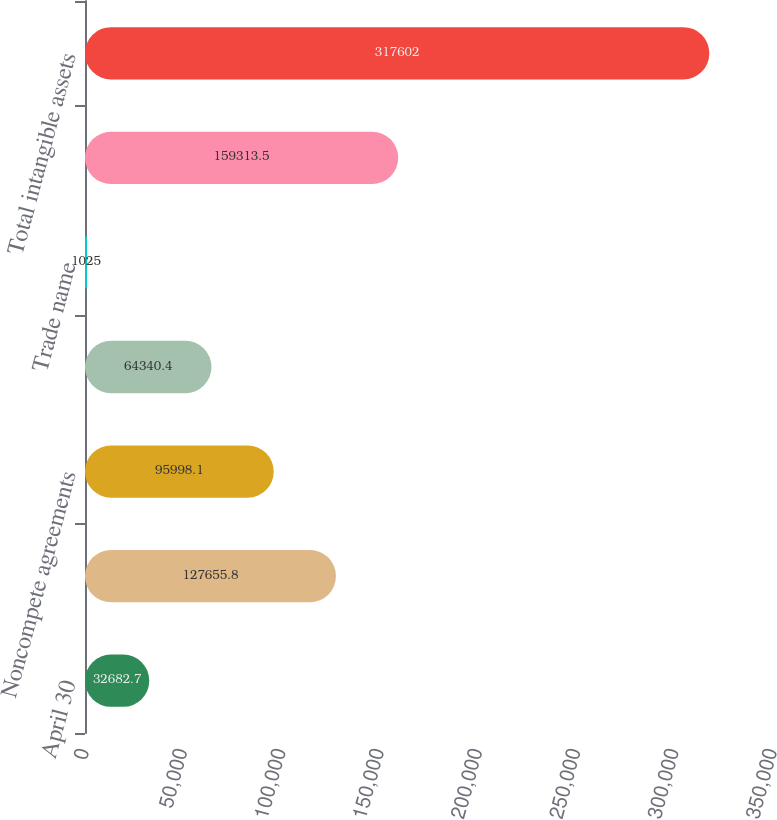Convert chart to OTSL. <chart><loc_0><loc_0><loc_500><loc_500><bar_chart><fcel>April 30<fcel>Customer relationships<fcel>Noncompete agreements<fcel>Purchased technology<fcel>Trade name<fcel>Trade name - non-amortizing<fcel>Total intangible assets<nl><fcel>32682.7<fcel>127656<fcel>95998.1<fcel>64340.4<fcel>1025<fcel>159314<fcel>317602<nl></chart> 